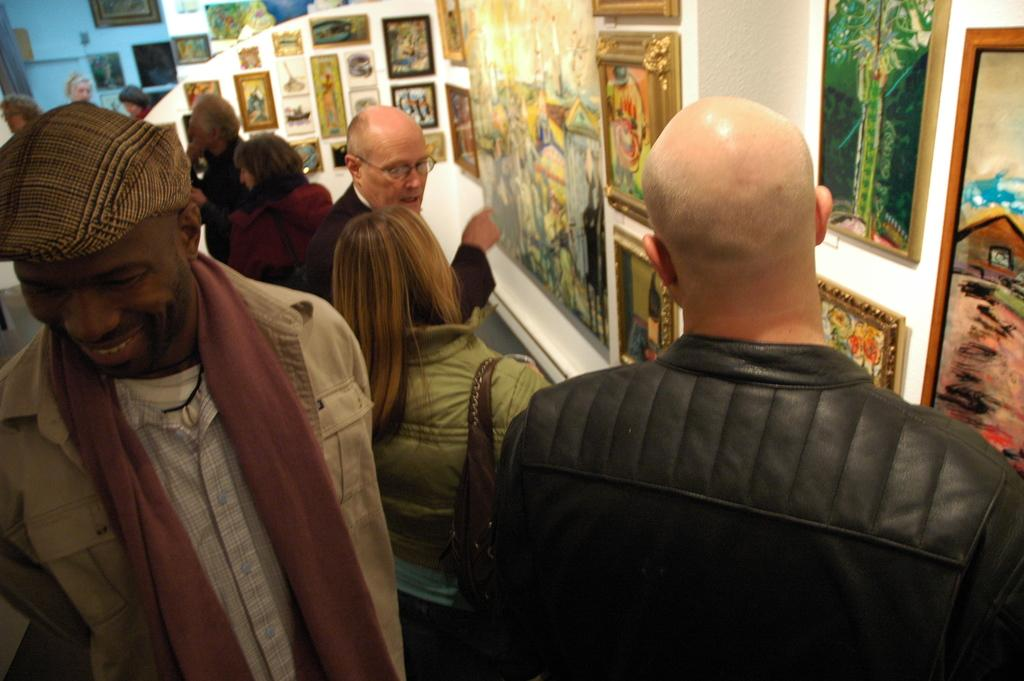What is happening in the image? There are people standing in the image. What can be seen on the right side of the image? There is a wall on the right side of the image. What is on the wall? There are portraits on the wall. Can you describe the appearance of one of the people in the image? A man in the front is wearing a cap. What type of system is being used by the people in the image? There is no specific system or technology being used by the people in the image; they are simply standing. What time of day is it in the image? The time of day cannot be determined from the image alone, as there are no clues about the lighting or time-related objects. 